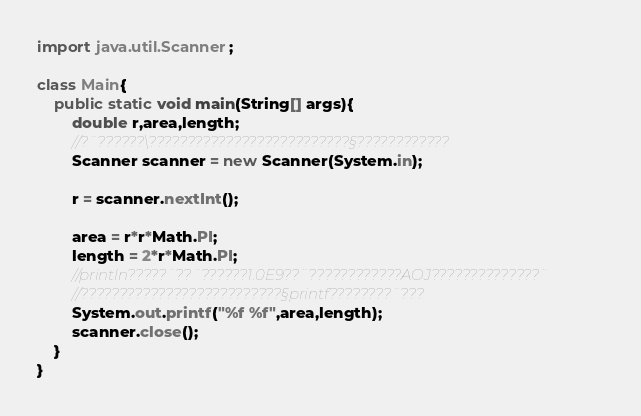Convert code to text. <code><loc_0><loc_0><loc_500><loc_500><_Java_>import java.util.Scanner;

class Main{
    public static void main(String[] args){
        double r,area,length;
    	//?¨??????\??????????????????????????§????????????
		Scanner scanner = new Scanner(System.in);

		r = scanner.nextInt();

    	area = r*r*Math.PI;
    	length = 2*r*Math.PI;
    	//println?????¨??¨??????1.0E9??¨????????????AOJ??????????????¨
    	//??????????????????????????§printf????????¨???
    	System.out.printf("%f %f",area,length);
    	scanner.close();
    }
}</code> 